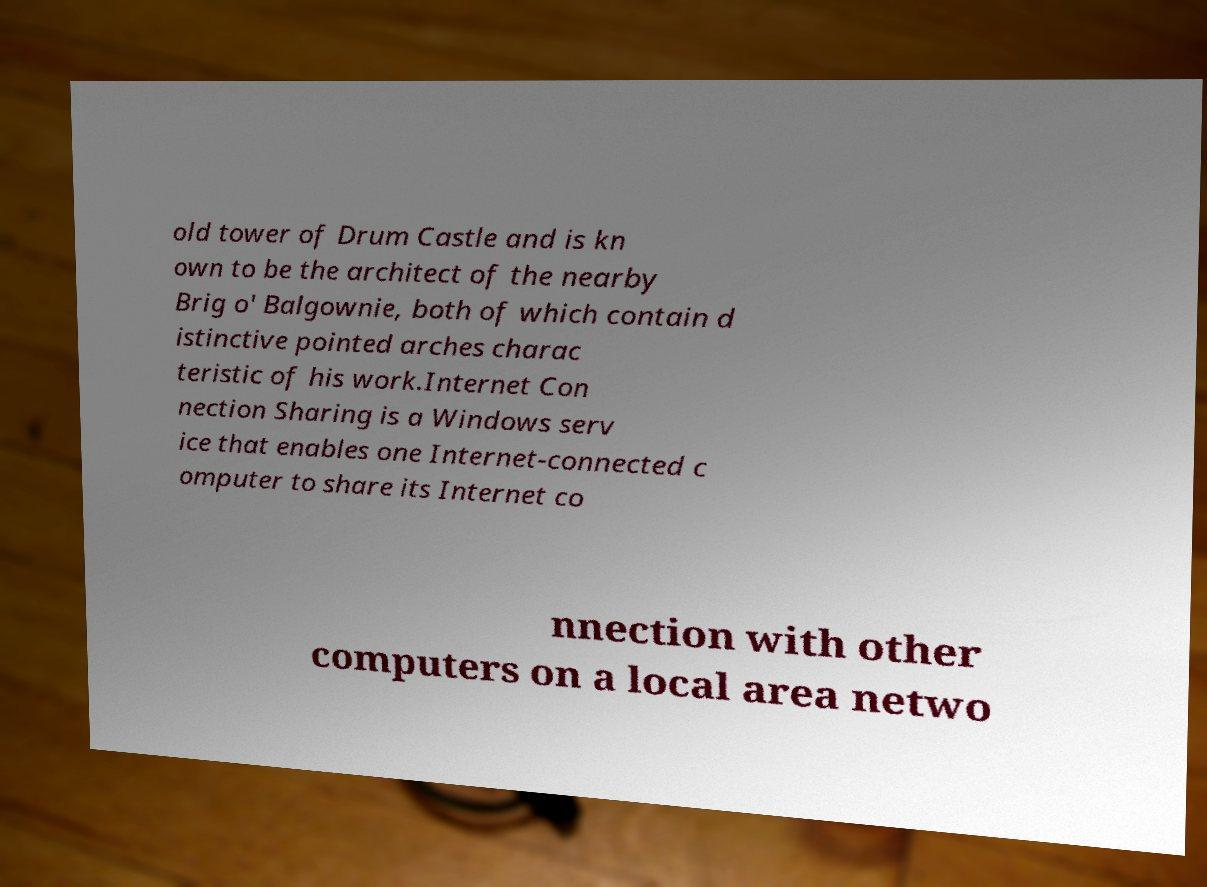Please read and relay the text visible in this image. What does it say? old tower of Drum Castle and is kn own to be the architect of the nearby Brig o' Balgownie, both of which contain d istinctive pointed arches charac teristic of his work.Internet Con nection Sharing is a Windows serv ice that enables one Internet-connected c omputer to share its Internet co nnection with other computers on a local area netwo 